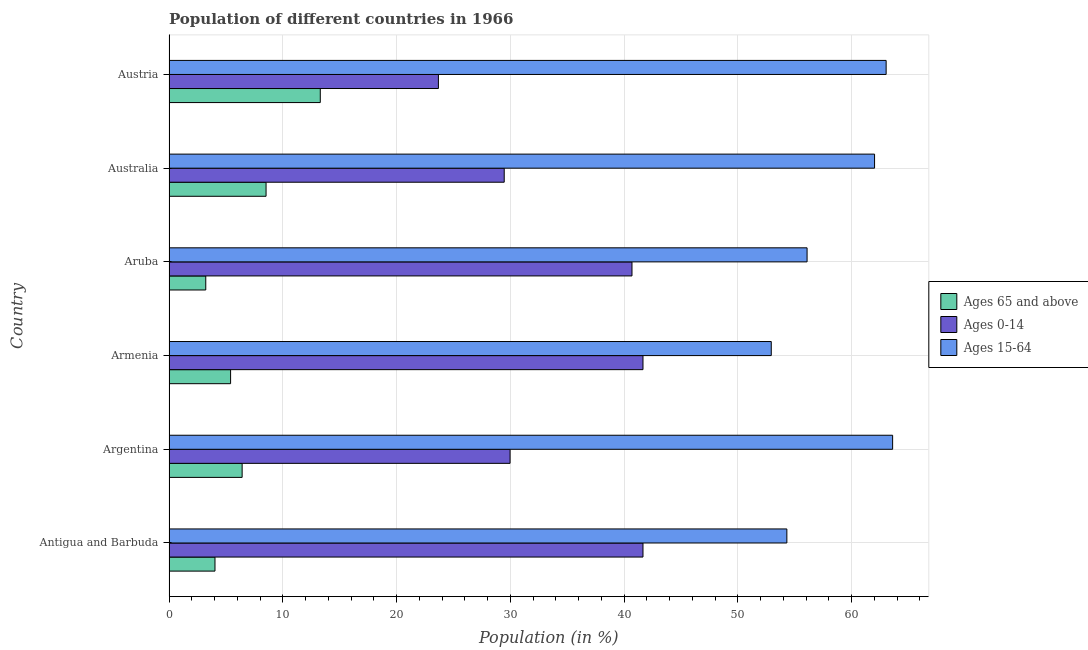Are the number of bars per tick equal to the number of legend labels?
Give a very brief answer. Yes. Are the number of bars on each tick of the Y-axis equal?
Make the answer very short. Yes. How many bars are there on the 4th tick from the top?
Your answer should be very brief. 3. How many bars are there on the 5th tick from the bottom?
Ensure brevity in your answer.  3. What is the percentage of population within the age-group of 65 and above in Australia?
Make the answer very short. 8.53. Across all countries, what is the maximum percentage of population within the age-group 0-14?
Your response must be concise. 41.66. Across all countries, what is the minimum percentage of population within the age-group 0-14?
Make the answer very short. 23.68. In which country was the percentage of population within the age-group 15-64 minimum?
Provide a short and direct response. Armenia. What is the total percentage of population within the age-group of 65 and above in the graph?
Provide a short and direct response. 40.94. What is the difference between the percentage of population within the age-group of 65 and above in Antigua and Barbuda and that in Austria?
Your response must be concise. -9.26. What is the difference between the percentage of population within the age-group 15-64 in Argentina and the percentage of population within the age-group 0-14 in Armenia?
Make the answer very short. 21.94. What is the average percentage of population within the age-group 15-64 per country?
Give a very brief answer. 58.66. What is the difference between the percentage of population within the age-group 0-14 and percentage of population within the age-group 15-64 in Armenia?
Your answer should be compact. -11.28. What is the ratio of the percentage of population within the age-group of 65 and above in Aruba to that in Australia?
Offer a very short reply. 0.38. Is the percentage of population within the age-group 0-14 in Argentina less than that in Aruba?
Your answer should be very brief. Yes. What is the difference between the highest and the second highest percentage of population within the age-group of 65 and above?
Offer a terse response. 4.77. What is the difference between the highest and the lowest percentage of population within the age-group of 65 and above?
Offer a terse response. 10.06. What does the 2nd bar from the top in Austria represents?
Offer a terse response. Ages 0-14. What does the 2nd bar from the bottom in Argentina represents?
Provide a short and direct response. Ages 0-14. Is it the case that in every country, the sum of the percentage of population within the age-group of 65 and above and percentage of population within the age-group 0-14 is greater than the percentage of population within the age-group 15-64?
Provide a short and direct response. No. What is the difference between two consecutive major ticks on the X-axis?
Make the answer very short. 10. Are the values on the major ticks of X-axis written in scientific E-notation?
Your response must be concise. No. How are the legend labels stacked?
Give a very brief answer. Vertical. What is the title of the graph?
Give a very brief answer. Population of different countries in 1966. Does "Ages 20-60" appear as one of the legend labels in the graph?
Give a very brief answer. No. What is the label or title of the X-axis?
Your answer should be compact. Population (in %). What is the label or title of the Y-axis?
Provide a succinct answer. Country. What is the Population (in %) in Ages 65 and above in Antigua and Barbuda?
Provide a succinct answer. 4.04. What is the Population (in %) in Ages 0-14 in Antigua and Barbuda?
Offer a very short reply. 41.66. What is the Population (in %) of Ages 15-64 in Antigua and Barbuda?
Offer a very short reply. 54.3. What is the Population (in %) of Ages 65 and above in Argentina?
Provide a succinct answer. 6.43. What is the Population (in %) in Ages 0-14 in Argentina?
Offer a terse response. 29.98. What is the Population (in %) of Ages 15-64 in Argentina?
Provide a succinct answer. 63.6. What is the Population (in %) of Ages 65 and above in Armenia?
Your answer should be compact. 5.41. What is the Population (in %) of Ages 0-14 in Armenia?
Ensure brevity in your answer.  41.66. What is the Population (in %) in Ages 15-64 in Armenia?
Ensure brevity in your answer.  52.93. What is the Population (in %) in Ages 65 and above in Aruba?
Your answer should be very brief. 3.23. What is the Population (in %) in Ages 0-14 in Aruba?
Ensure brevity in your answer.  40.69. What is the Population (in %) of Ages 15-64 in Aruba?
Keep it short and to the point. 56.08. What is the Population (in %) in Ages 65 and above in Australia?
Your answer should be compact. 8.53. What is the Population (in %) in Ages 0-14 in Australia?
Provide a short and direct response. 29.46. What is the Population (in %) of Ages 15-64 in Australia?
Make the answer very short. 62.01. What is the Population (in %) in Ages 65 and above in Austria?
Provide a short and direct response. 13.3. What is the Population (in %) of Ages 0-14 in Austria?
Make the answer very short. 23.68. What is the Population (in %) of Ages 15-64 in Austria?
Your response must be concise. 63.03. Across all countries, what is the maximum Population (in %) of Ages 65 and above?
Your response must be concise. 13.3. Across all countries, what is the maximum Population (in %) in Ages 0-14?
Ensure brevity in your answer.  41.66. Across all countries, what is the maximum Population (in %) of Ages 15-64?
Keep it short and to the point. 63.6. Across all countries, what is the minimum Population (in %) in Ages 65 and above?
Make the answer very short. 3.23. Across all countries, what is the minimum Population (in %) of Ages 0-14?
Give a very brief answer. 23.68. Across all countries, what is the minimum Population (in %) in Ages 15-64?
Your answer should be compact. 52.93. What is the total Population (in %) in Ages 65 and above in the graph?
Make the answer very short. 40.94. What is the total Population (in %) of Ages 0-14 in the graph?
Your answer should be compact. 207.12. What is the total Population (in %) in Ages 15-64 in the graph?
Your response must be concise. 351.94. What is the difference between the Population (in %) of Ages 65 and above in Antigua and Barbuda and that in Argentina?
Make the answer very short. -2.39. What is the difference between the Population (in %) in Ages 0-14 in Antigua and Barbuda and that in Argentina?
Your response must be concise. 11.68. What is the difference between the Population (in %) of Ages 15-64 in Antigua and Barbuda and that in Argentina?
Your response must be concise. -9.3. What is the difference between the Population (in %) of Ages 65 and above in Antigua and Barbuda and that in Armenia?
Provide a succinct answer. -1.37. What is the difference between the Population (in %) in Ages 0-14 in Antigua and Barbuda and that in Armenia?
Your answer should be very brief. 0. What is the difference between the Population (in %) of Ages 15-64 in Antigua and Barbuda and that in Armenia?
Provide a short and direct response. 1.37. What is the difference between the Population (in %) of Ages 65 and above in Antigua and Barbuda and that in Aruba?
Provide a succinct answer. 0.81. What is the difference between the Population (in %) of Ages 0-14 in Antigua and Barbuda and that in Aruba?
Ensure brevity in your answer.  0.97. What is the difference between the Population (in %) of Ages 15-64 in Antigua and Barbuda and that in Aruba?
Give a very brief answer. -1.78. What is the difference between the Population (in %) of Ages 65 and above in Antigua and Barbuda and that in Australia?
Make the answer very short. -4.49. What is the difference between the Population (in %) of Ages 0-14 in Antigua and Barbuda and that in Australia?
Your response must be concise. 12.2. What is the difference between the Population (in %) in Ages 15-64 in Antigua and Barbuda and that in Australia?
Your answer should be compact. -7.71. What is the difference between the Population (in %) of Ages 65 and above in Antigua and Barbuda and that in Austria?
Give a very brief answer. -9.25. What is the difference between the Population (in %) in Ages 0-14 in Antigua and Barbuda and that in Austria?
Your answer should be compact. 17.98. What is the difference between the Population (in %) of Ages 15-64 in Antigua and Barbuda and that in Austria?
Give a very brief answer. -8.73. What is the difference between the Population (in %) of Ages 65 and above in Argentina and that in Armenia?
Offer a very short reply. 1.01. What is the difference between the Population (in %) in Ages 0-14 in Argentina and that in Armenia?
Keep it short and to the point. -11.68. What is the difference between the Population (in %) in Ages 15-64 in Argentina and that in Armenia?
Ensure brevity in your answer.  10.67. What is the difference between the Population (in %) in Ages 65 and above in Argentina and that in Aruba?
Give a very brief answer. 3.2. What is the difference between the Population (in %) in Ages 0-14 in Argentina and that in Aruba?
Your answer should be compact. -10.71. What is the difference between the Population (in %) in Ages 15-64 in Argentina and that in Aruba?
Provide a succinct answer. 7.52. What is the difference between the Population (in %) in Ages 65 and above in Argentina and that in Australia?
Offer a terse response. -2.1. What is the difference between the Population (in %) of Ages 0-14 in Argentina and that in Australia?
Keep it short and to the point. 0.52. What is the difference between the Population (in %) in Ages 15-64 in Argentina and that in Australia?
Your response must be concise. 1.59. What is the difference between the Population (in %) in Ages 65 and above in Argentina and that in Austria?
Ensure brevity in your answer.  -6.87. What is the difference between the Population (in %) in Ages 0-14 in Argentina and that in Austria?
Your answer should be very brief. 6.3. What is the difference between the Population (in %) in Ages 15-64 in Argentina and that in Austria?
Offer a terse response. 0.57. What is the difference between the Population (in %) in Ages 65 and above in Armenia and that in Aruba?
Your response must be concise. 2.18. What is the difference between the Population (in %) of Ages 0-14 in Armenia and that in Aruba?
Ensure brevity in your answer.  0.97. What is the difference between the Population (in %) of Ages 15-64 in Armenia and that in Aruba?
Provide a succinct answer. -3.15. What is the difference between the Population (in %) of Ages 65 and above in Armenia and that in Australia?
Provide a short and direct response. -3.12. What is the difference between the Population (in %) of Ages 0-14 in Armenia and that in Australia?
Ensure brevity in your answer.  12.2. What is the difference between the Population (in %) in Ages 15-64 in Armenia and that in Australia?
Your answer should be compact. -9.08. What is the difference between the Population (in %) in Ages 65 and above in Armenia and that in Austria?
Your answer should be very brief. -7.88. What is the difference between the Population (in %) in Ages 0-14 in Armenia and that in Austria?
Keep it short and to the point. 17.98. What is the difference between the Population (in %) in Ages 15-64 in Armenia and that in Austria?
Give a very brief answer. -10.1. What is the difference between the Population (in %) in Ages 65 and above in Aruba and that in Australia?
Offer a very short reply. -5.3. What is the difference between the Population (in %) of Ages 0-14 in Aruba and that in Australia?
Make the answer very short. 11.23. What is the difference between the Population (in %) in Ages 15-64 in Aruba and that in Australia?
Ensure brevity in your answer.  -5.93. What is the difference between the Population (in %) in Ages 65 and above in Aruba and that in Austria?
Provide a succinct answer. -10.06. What is the difference between the Population (in %) in Ages 0-14 in Aruba and that in Austria?
Offer a very short reply. 17.01. What is the difference between the Population (in %) of Ages 15-64 in Aruba and that in Austria?
Provide a succinct answer. -6.95. What is the difference between the Population (in %) in Ages 65 and above in Australia and that in Austria?
Your answer should be very brief. -4.77. What is the difference between the Population (in %) of Ages 0-14 in Australia and that in Austria?
Provide a short and direct response. 5.78. What is the difference between the Population (in %) in Ages 15-64 in Australia and that in Austria?
Provide a succinct answer. -1.02. What is the difference between the Population (in %) in Ages 65 and above in Antigua and Barbuda and the Population (in %) in Ages 0-14 in Argentina?
Give a very brief answer. -25.93. What is the difference between the Population (in %) of Ages 65 and above in Antigua and Barbuda and the Population (in %) of Ages 15-64 in Argentina?
Provide a succinct answer. -59.55. What is the difference between the Population (in %) of Ages 0-14 in Antigua and Barbuda and the Population (in %) of Ages 15-64 in Argentina?
Provide a short and direct response. -21.94. What is the difference between the Population (in %) in Ages 65 and above in Antigua and Barbuda and the Population (in %) in Ages 0-14 in Armenia?
Make the answer very short. -37.61. What is the difference between the Population (in %) in Ages 65 and above in Antigua and Barbuda and the Population (in %) in Ages 15-64 in Armenia?
Your answer should be very brief. -48.89. What is the difference between the Population (in %) in Ages 0-14 in Antigua and Barbuda and the Population (in %) in Ages 15-64 in Armenia?
Your response must be concise. -11.27. What is the difference between the Population (in %) of Ages 65 and above in Antigua and Barbuda and the Population (in %) of Ages 0-14 in Aruba?
Provide a short and direct response. -36.65. What is the difference between the Population (in %) of Ages 65 and above in Antigua and Barbuda and the Population (in %) of Ages 15-64 in Aruba?
Ensure brevity in your answer.  -52.04. What is the difference between the Population (in %) of Ages 0-14 in Antigua and Barbuda and the Population (in %) of Ages 15-64 in Aruba?
Offer a terse response. -14.42. What is the difference between the Population (in %) in Ages 65 and above in Antigua and Barbuda and the Population (in %) in Ages 0-14 in Australia?
Ensure brevity in your answer.  -25.42. What is the difference between the Population (in %) in Ages 65 and above in Antigua and Barbuda and the Population (in %) in Ages 15-64 in Australia?
Give a very brief answer. -57.97. What is the difference between the Population (in %) of Ages 0-14 in Antigua and Barbuda and the Population (in %) of Ages 15-64 in Australia?
Your answer should be compact. -20.35. What is the difference between the Population (in %) in Ages 65 and above in Antigua and Barbuda and the Population (in %) in Ages 0-14 in Austria?
Make the answer very short. -19.64. What is the difference between the Population (in %) in Ages 65 and above in Antigua and Barbuda and the Population (in %) in Ages 15-64 in Austria?
Make the answer very short. -58.98. What is the difference between the Population (in %) in Ages 0-14 in Antigua and Barbuda and the Population (in %) in Ages 15-64 in Austria?
Offer a very short reply. -21.37. What is the difference between the Population (in %) of Ages 65 and above in Argentina and the Population (in %) of Ages 0-14 in Armenia?
Provide a short and direct response. -35.23. What is the difference between the Population (in %) of Ages 65 and above in Argentina and the Population (in %) of Ages 15-64 in Armenia?
Keep it short and to the point. -46.5. What is the difference between the Population (in %) of Ages 0-14 in Argentina and the Population (in %) of Ages 15-64 in Armenia?
Your answer should be compact. -22.96. What is the difference between the Population (in %) in Ages 65 and above in Argentina and the Population (in %) in Ages 0-14 in Aruba?
Give a very brief answer. -34.26. What is the difference between the Population (in %) in Ages 65 and above in Argentina and the Population (in %) in Ages 15-64 in Aruba?
Give a very brief answer. -49.65. What is the difference between the Population (in %) in Ages 0-14 in Argentina and the Population (in %) in Ages 15-64 in Aruba?
Ensure brevity in your answer.  -26.1. What is the difference between the Population (in %) of Ages 65 and above in Argentina and the Population (in %) of Ages 0-14 in Australia?
Keep it short and to the point. -23.03. What is the difference between the Population (in %) of Ages 65 and above in Argentina and the Population (in %) of Ages 15-64 in Australia?
Keep it short and to the point. -55.58. What is the difference between the Population (in %) in Ages 0-14 in Argentina and the Population (in %) in Ages 15-64 in Australia?
Your response must be concise. -32.03. What is the difference between the Population (in %) in Ages 65 and above in Argentina and the Population (in %) in Ages 0-14 in Austria?
Offer a very short reply. -17.25. What is the difference between the Population (in %) of Ages 65 and above in Argentina and the Population (in %) of Ages 15-64 in Austria?
Make the answer very short. -56.6. What is the difference between the Population (in %) in Ages 0-14 in Argentina and the Population (in %) in Ages 15-64 in Austria?
Offer a very short reply. -33.05. What is the difference between the Population (in %) of Ages 65 and above in Armenia and the Population (in %) of Ages 0-14 in Aruba?
Your answer should be compact. -35.28. What is the difference between the Population (in %) in Ages 65 and above in Armenia and the Population (in %) in Ages 15-64 in Aruba?
Ensure brevity in your answer.  -50.67. What is the difference between the Population (in %) in Ages 0-14 in Armenia and the Population (in %) in Ages 15-64 in Aruba?
Keep it short and to the point. -14.42. What is the difference between the Population (in %) in Ages 65 and above in Armenia and the Population (in %) in Ages 0-14 in Australia?
Your response must be concise. -24.05. What is the difference between the Population (in %) in Ages 65 and above in Armenia and the Population (in %) in Ages 15-64 in Australia?
Your response must be concise. -56.6. What is the difference between the Population (in %) in Ages 0-14 in Armenia and the Population (in %) in Ages 15-64 in Australia?
Keep it short and to the point. -20.35. What is the difference between the Population (in %) in Ages 65 and above in Armenia and the Population (in %) in Ages 0-14 in Austria?
Keep it short and to the point. -18.26. What is the difference between the Population (in %) in Ages 65 and above in Armenia and the Population (in %) in Ages 15-64 in Austria?
Ensure brevity in your answer.  -57.61. What is the difference between the Population (in %) of Ages 0-14 in Armenia and the Population (in %) of Ages 15-64 in Austria?
Provide a succinct answer. -21.37. What is the difference between the Population (in %) of Ages 65 and above in Aruba and the Population (in %) of Ages 0-14 in Australia?
Give a very brief answer. -26.23. What is the difference between the Population (in %) in Ages 65 and above in Aruba and the Population (in %) in Ages 15-64 in Australia?
Provide a succinct answer. -58.78. What is the difference between the Population (in %) in Ages 0-14 in Aruba and the Population (in %) in Ages 15-64 in Australia?
Make the answer very short. -21.32. What is the difference between the Population (in %) of Ages 65 and above in Aruba and the Population (in %) of Ages 0-14 in Austria?
Provide a succinct answer. -20.45. What is the difference between the Population (in %) of Ages 65 and above in Aruba and the Population (in %) of Ages 15-64 in Austria?
Provide a succinct answer. -59.8. What is the difference between the Population (in %) in Ages 0-14 in Aruba and the Population (in %) in Ages 15-64 in Austria?
Your answer should be compact. -22.34. What is the difference between the Population (in %) in Ages 65 and above in Australia and the Population (in %) in Ages 0-14 in Austria?
Give a very brief answer. -15.15. What is the difference between the Population (in %) in Ages 65 and above in Australia and the Population (in %) in Ages 15-64 in Austria?
Ensure brevity in your answer.  -54.5. What is the difference between the Population (in %) of Ages 0-14 in Australia and the Population (in %) of Ages 15-64 in Austria?
Offer a terse response. -33.57. What is the average Population (in %) of Ages 65 and above per country?
Your response must be concise. 6.82. What is the average Population (in %) of Ages 0-14 per country?
Offer a very short reply. 34.52. What is the average Population (in %) of Ages 15-64 per country?
Ensure brevity in your answer.  58.66. What is the difference between the Population (in %) of Ages 65 and above and Population (in %) of Ages 0-14 in Antigua and Barbuda?
Give a very brief answer. -37.62. What is the difference between the Population (in %) of Ages 65 and above and Population (in %) of Ages 15-64 in Antigua and Barbuda?
Offer a very short reply. -50.26. What is the difference between the Population (in %) of Ages 0-14 and Population (in %) of Ages 15-64 in Antigua and Barbuda?
Make the answer very short. -12.64. What is the difference between the Population (in %) in Ages 65 and above and Population (in %) in Ages 0-14 in Argentina?
Provide a short and direct response. -23.55. What is the difference between the Population (in %) in Ages 65 and above and Population (in %) in Ages 15-64 in Argentina?
Provide a short and direct response. -57.17. What is the difference between the Population (in %) of Ages 0-14 and Population (in %) of Ages 15-64 in Argentina?
Give a very brief answer. -33.62. What is the difference between the Population (in %) in Ages 65 and above and Population (in %) in Ages 0-14 in Armenia?
Offer a terse response. -36.24. What is the difference between the Population (in %) of Ages 65 and above and Population (in %) of Ages 15-64 in Armenia?
Offer a terse response. -47.52. What is the difference between the Population (in %) in Ages 0-14 and Population (in %) in Ages 15-64 in Armenia?
Provide a short and direct response. -11.27. What is the difference between the Population (in %) in Ages 65 and above and Population (in %) in Ages 0-14 in Aruba?
Give a very brief answer. -37.46. What is the difference between the Population (in %) of Ages 65 and above and Population (in %) of Ages 15-64 in Aruba?
Give a very brief answer. -52.85. What is the difference between the Population (in %) in Ages 0-14 and Population (in %) in Ages 15-64 in Aruba?
Offer a very short reply. -15.39. What is the difference between the Population (in %) of Ages 65 and above and Population (in %) of Ages 0-14 in Australia?
Your response must be concise. -20.93. What is the difference between the Population (in %) in Ages 65 and above and Population (in %) in Ages 15-64 in Australia?
Offer a very short reply. -53.48. What is the difference between the Population (in %) in Ages 0-14 and Population (in %) in Ages 15-64 in Australia?
Your answer should be compact. -32.55. What is the difference between the Population (in %) of Ages 65 and above and Population (in %) of Ages 0-14 in Austria?
Provide a short and direct response. -10.38. What is the difference between the Population (in %) of Ages 65 and above and Population (in %) of Ages 15-64 in Austria?
Your response must be concise. -49.73. What is the difference between the Population (in %) in Ages 0-14 and Population (in %) in Ages 15-64 in Austria?
Provide a succinct answer. -39.35. What is the ratio of the Population (in %) of Ages 65 and above in Antigua and Barbuda to that in Argentina?
Make the answer very short. 0.63. What is the ratio of the Population (in %) of Ages 0-14 in Antigua and Barbuda to that in Argentina?
Give a very brief answer. 1.39. What is the ratio of the Population (in %) in Ages 15-64 in Antigua and Barbuda to that in Argentina?
Keep it short and to the point. 0.85. What is the ratio of the Population (in %) of Ages 65 and above in Antigua and Barbuda to that in Armenia?
Offer a terse response. 0.75. What is the ratio of the Population (in %) of Ages 0-14 in Antigua and Barbuda to that in Armenia?
Provide a short and direct response. 1. What is the ratio of the Population (in %) of Ages 15-64 in Antigua and Barbuda to that in Armenia?
Give a very brief answer. 1.03. What is the ratio of the Population (in %) of Ages 65 and above in Antigua and Barbuda to that in Aruba?
Provide a short and direct response. 1.25. What is the ratio of the Population (in %) in Ages 0-14 in Antigua and Barbuda to that in Aruba?
Your answer should be compact. 1.02. What is the ratio of the Population (in %) of Ages 15-64 in Antigua and Barbuda to that in Aruba?
Your answer should be compact. 0.97. What is the ratio of the Population (in %) in Ages 65 and above in Antigua and Barbuda to that in Australia?
Provide a succinct answer. 0.47. What is the ratio of the Population (in %) in Ages 0-14 in Antigua and Barbuda to that in Australia?
Your answer should be compact. 1.41. What is the ratio of the Population (in %) of Ages 15-64 in Antigua and Barbuda to that in Australia?
Provide a short and direct response. 0.88. What is the ratio of the Population (in %) in Ages 65 and above in Antigua and Barbuda to that in Austria?
Provide a short and direct response. 0.3. What is the ratio of the Population (in %) of Ages 0-14 in Antigua and Barbuda to that in Austria?
Provide a succinct answer. 1.76. What is the ratio of the Population (in %) in Ages 15-64 in Antigua and Barbuda to that in Austria?
Offer a very short reply. 0.86. What is the ratio of the Population (in %) in Ages 65 and above in Argentina to that in Armenia?
Your response must be concise. 1.19. What is the ratio of the Population (in %) of Ages 0-14 in Argentina to that in Armenia?
Keep it short and to the point. 0.72. What is the ratio of the Population (in %) in Ages 15-64 in Argentina to that in Armenia?
Your response must be concise. 1.2. What is the ratio of the Population (in %) in Ages 65 and above in Argentina to that in Aruba?
Keep it short and to the point. 1.99. What is the ratio of the Population (in %) of Ages 0-14 in Argentina to that in Aruba?
Provide a succinct answer. 0.74. What is the ratio of the Population (in %) of Ages 15-64 in Argentina to that in Aruba?
Your response must be concise. 1.13. What is the ratio of the Population (in %) in Ages 65 and above in Argentina to that in Australia?
Offer a very short reply. 0.75. What is the ratio of the Population (in %) of Ages 0-14 in Argentina to that in Australia?
Keep it short and to the point. 1.02. What is the ratio of the Population (in %) in Ages 15-64 in Argentina to that in Australia?
Ensure brevity in your answer.  1.03. What is the ratio of the Population (in %) in Ages 65 and above in Argentina to that in Austria?
Provide a succinct answer. 0.48. What is the ratio of the Population (in %) in Ages 0-14 in Argentina to that in Austria?
Your answer should be very brief. 1.27. What is the ratio of the Population (in %) in Ages 15-64 in Argentina to that in Austria?
Give a very brief answer. 1.01. What is the ratio of the Population (in %) of Ages 65 and above in Armenia to that in Aruba?
Your answer should be compact. 1.68. What is the ratio of the Population (in %) in Ages 0-14 in Armenia to that in Aruba?
Your response must be concise. 1.02. What is the ratio of the Population (in %) of Ages 15-64 in Armenia to that in Aruba?
Provide a succinct answer. 0.94. What is the ratio of the Population (in %) in Ages 65 and above in Armenia to that in Australia?
Provide a succinct answer. 0.63. What is the ratio of the Population (in %) in Ages 0-14 in Armenia to that in Australia?
Provide a succinct answer. 1.41. What is the ratio of the Population (in %) of Ages 15-64 in Armenia to that in Australia?
Ensure brevity in your answer.  0.85. What is the ratio of the Population (in %) in Ages 65 and above in Armenia to that in Austria?
Provide a short and direct response. 0.41. What is the ratio of the Population (in %) of Ages 0-14 in Armenia to that in Austria?
Your answer should be compact. 1.76. What is the ratio of the Population (in %) of Ages 15-64 in Armenia to that in Austria?
Provide a succinct answer. 0.84. What is the ratio of the Population (in %) in Ages 65 and above in Aruba to that in Australia?
Your response must be concise. 0.38. What is the ratio of the Population (in %) of Ages 0-14 in Aruba to that in Australia?
Offer a terse response. 1.38. What is the ratio of the Population (in %) in Ages 15-64 in Aruba to that in Australia?
Your answer should be compact. 0.9. What is the ratio of the Population (in %) of Ages 65 and above in Aruba to that in Austria?
Offer a terse response. 0.24. What is the ratio of the Population (in %) in Ages 0-14 in Aruba to that in Austria?
Your answer should be very brief. 1.72. What is the ratio of the Population (in %) of Ages 15-64 in Aruba to that in Austria?
Your response must be concise. 0.89. What is the ratio of the Population (in %) in Ages 65 and above in Australia to that in Austria?
Offer a very short reply. 0.64. What is the ratio of the Population (in %) of Ages 0-14 in Australia to that in Austria?
Offer a very short reply. 1.24. What is the ratio of the Population (in %) of Ages 15-64 in Australia to that in Austria?
Your answer should be very brief. 0.98. What is the difference between the highest and the second highest Population (in %) of Ages 65 and above?
Your answer should be compact. 4.77. What is the difference between the highest and the second highest Population (in %) of Ages 0-14?
Make the answer very short. 0. What is the difference between the highest and the second highest Population (in %) of Ages 15-64?
Your answer should be compact. 0.57. What is the difference between the highest and the lowest Population (in %) of Ages 65 and above?
Your answer should be compact. 10.06. What is the difference between the highest and the lowest Population (in %) of Ages 0-14?
Keep it short and to the point. 17.98. What is the difference between the highest and the lowest Population (in %) in Ages 15-64?
Provide a succinct answer. 10.67. 